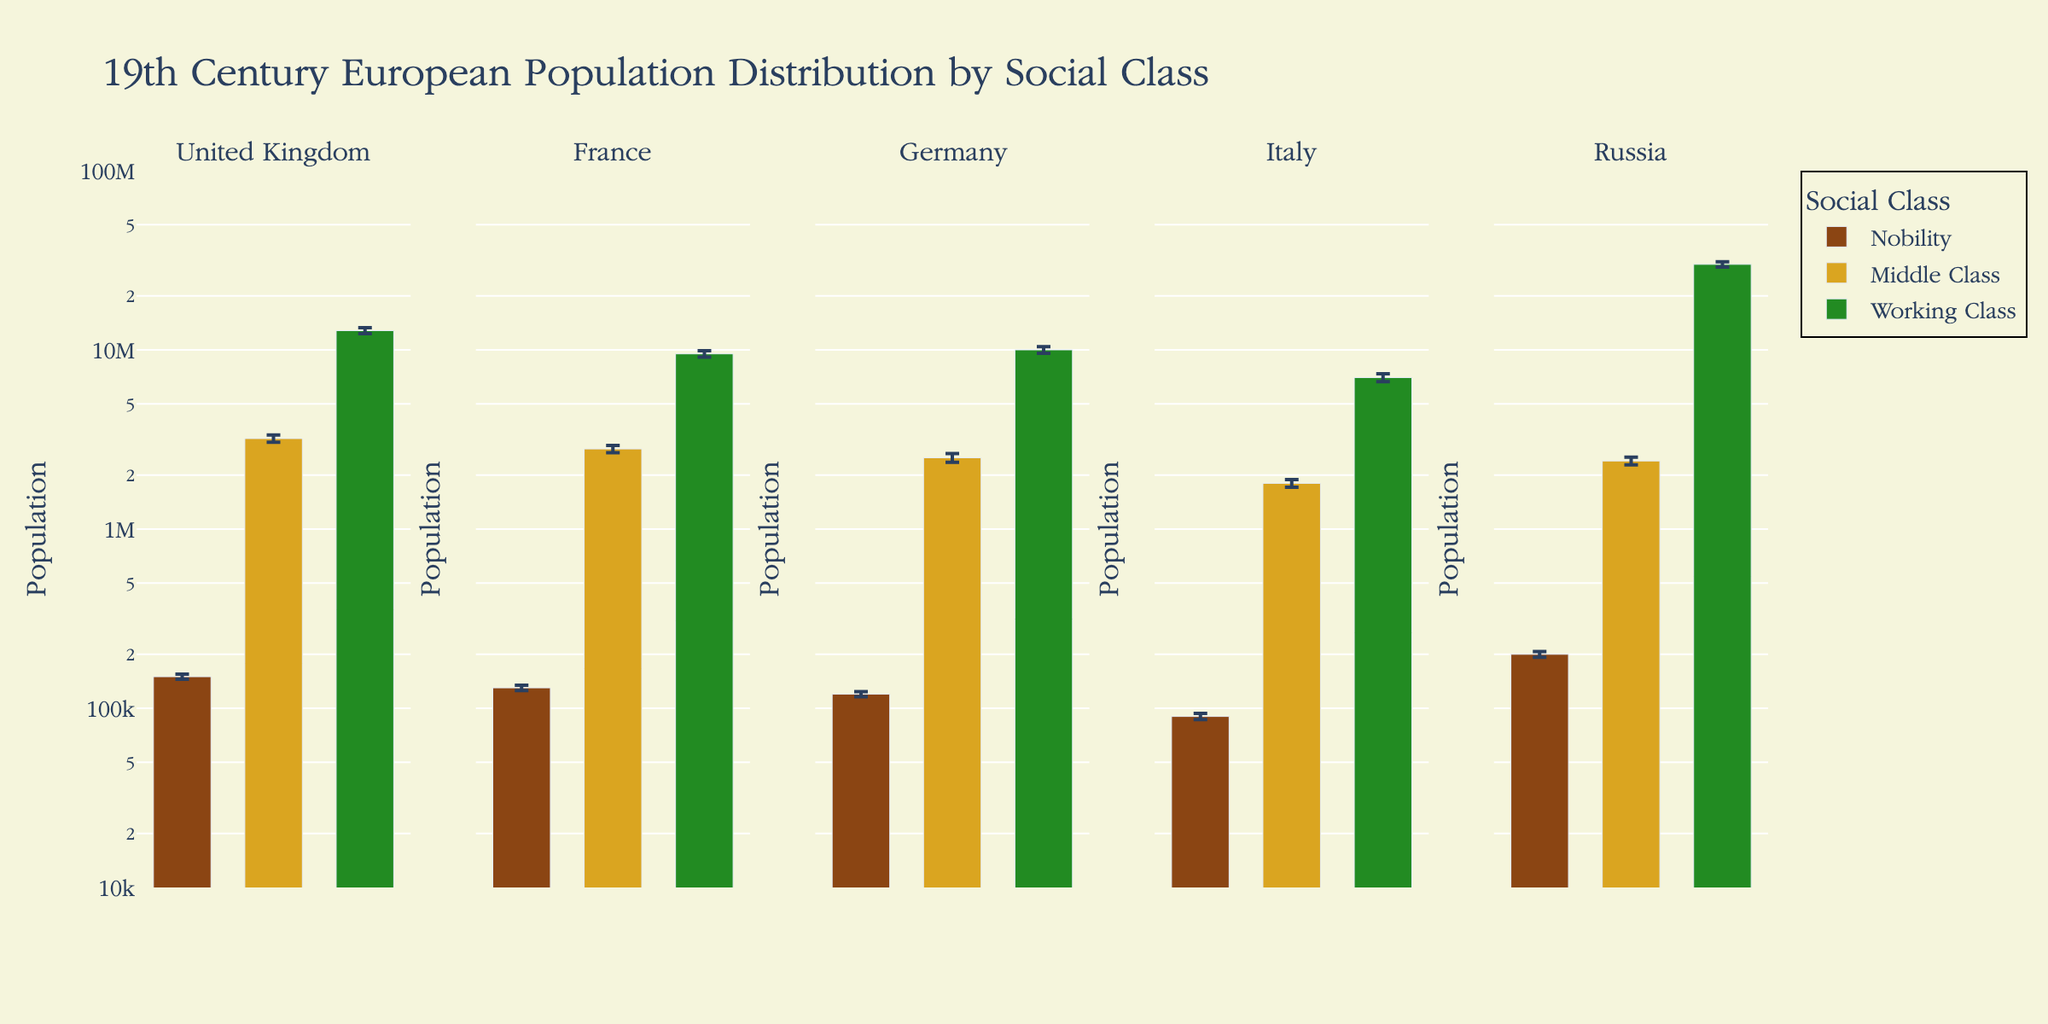What is the title of the figure? The title is located at the top of the figure. By reading it, you can see that it is "19th Century European Population Distribution by Social Class".
Answer: 19th Century European Population Distribution by Social Class Which country has the largest working-class population? To find this, identify the working-class segment in each country's subplot and compare their heights. Russia's working class bar is the tallest among them.
Answer: Russia What is the total population of the nobility class in all countries combined? Add the population of the nobility class from each country: 150,000 (UK) + 130,000 (France) + 120,000 (Germany) + 90,000 (Italy) + 200,000 (Russia) = 690,000.
Answer: 690,000 Which social class has the smallest standard error across all countries? Compare the standard errors of each social class segment. Nobility, with errors of 5000, 4500, 4000, 3500, and 7500, has consistently smaller standard errors compared to other classes.
Answer: Nobility In which country is the middle-class population approximately equal to the working-class population of Germany? The middle-class bar for Russia, with a population of 2.4 million, closely matches Germany's working-class bar, which is 10 million.
Answer: Russia Which social class has the largest variation in population across different countries? Compare the range (difference) of populations for each social class across countries. The working class shows the largest variation, with Russia having 30 million and Italy having 7 million.
Answer: Working Class How does the population of the middle class in the United Kingdom compare to that in Germany? Compare the height of the middle-class bars in the United Kingdom and Germany subplots. UK's middle class is slightly higher than Germany’s, with UK at 3.2 million and Germany at 2.5 million.
Answer: United Kingdom has a higher population Are the populations of the nobility significant when compared to the working-class populations? Compare the height of the nobility bars to the working-class bars within each subplot. The nobility populations are significantly smaller compared to the working-class populations in all countries.
Answer: No, they are significantly smaller 